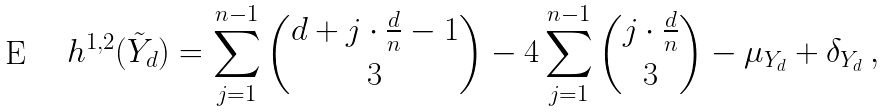<formula> <loc_0><loc_0><loc_500><loc_500>h ^ { 1 , 2 } ( \tilde { Y } _ { d } ) = \sum _ { j = 1 } ^ { n - 1 } { d + j \cdot \frac { d } { n } - 1 \choose 3 } - 4 \sum _ { j = 1 } ^ { n - 1 } { j \cdot \frac { d } { n } \choose 3 } - \mu _ { Y _ { d } } + \delta _ { Y _ { d } } \, ,</formula> 